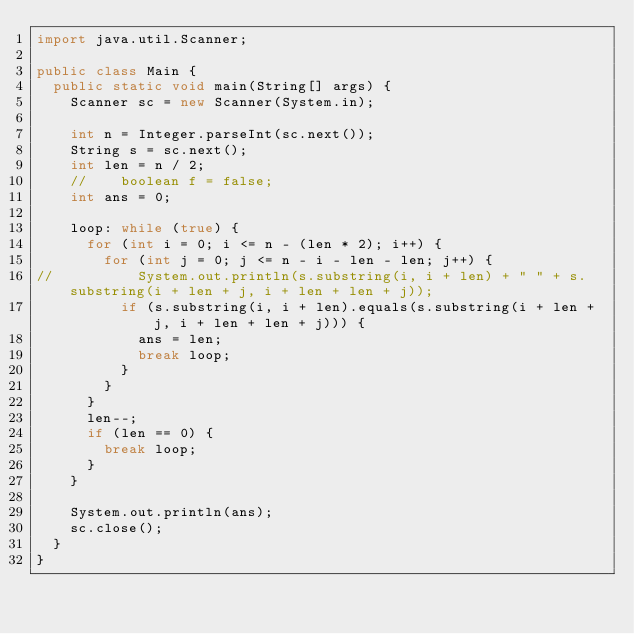Convert code to text. <code><loc_0><loc_0><loc_500><loc_500><_Java_>import java.util.Scanner;

public class Main {
	public static void main(String[] args) {
		Scanner sc = new Scanner(System.in);

		int n = Integer.parseInt(sc.next());
		String s = sc.next();
		int len = n / 2;
		//		boolean f = false;
		int ans = 0;

		loop: while (true) {
			for (int i = 0; i <= n - (len * 2); i++) {
				for (int j = 0; j <= n - i - len - len; j++) {
//					System.out.println(s.substring(i, i + len) + " " + s.substring(i + len + j, i + len + len + j));
					if (s.substring(i, i + len).equals(s.substring(i + len + j, i + len + len + j))) {
						ans = len;
						break loop;
					}
				}
			}
			len--;
			if (len == 0) {
				break loop;
			}
		}

		System.out.println(ans);
		sc.close();
	}
}</code> 